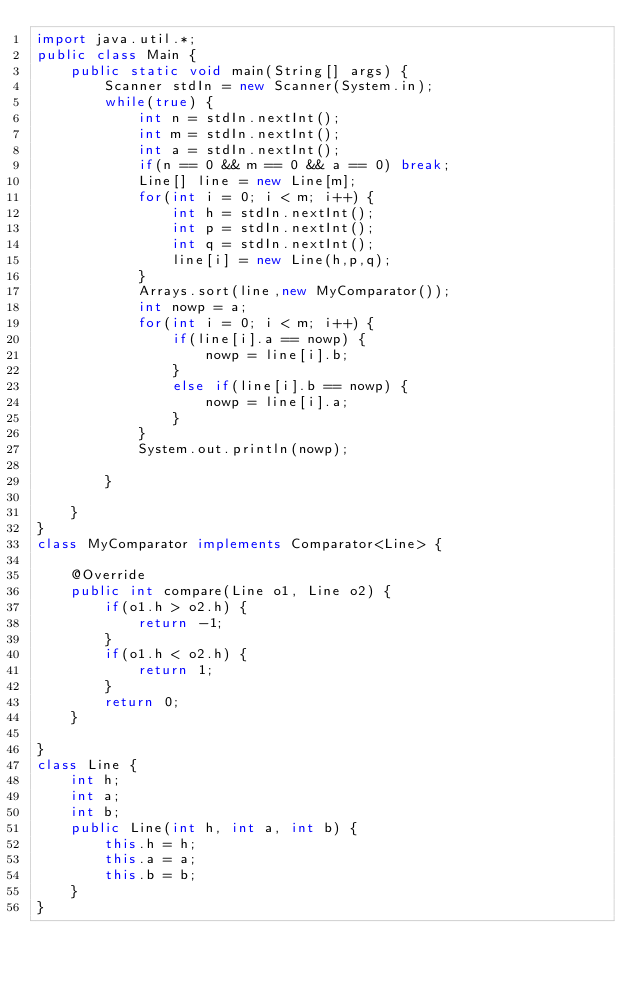<code> <loc_0><loc_0><loc_500><loc_500><_Java_>import java.util.*;
public class Main {
	public static void main(String[] args) {
		Scanner stdIn = new Scanner(System.in);
		while(true) {
			int n = stdIn.nextInt();
			int m = stdIn.nextInt();
			int a = stdIn.nextInt();
			if(n == 0 && m == 0 && a == 0) break;
			Line[] line = new Line[m];
			for(int i = 0; i < m; i++) {
				int h = stdIn.nextInt();
				int p = stdIn.nextInt();
				int q = stdIn.nextInt();
				line[i] = new Line(h,p,q);
			}
			Arrays.sort(line,new MyComparator());
			int nowp = a;
			for(int i = 0; i < m; i++) {
				if(line[i].a == nowp) {
					nowp = line[i].b;
				}
				else if(line[i].b == nowp) {
					nowp = line[i].a;
				}
			}
			System.out.println(nowp);
			
		}
		
	}
}
class MyComparator implements Comparator<Line> {

	@Override
	public int compare(Line o1, Line o2) {
		if(o1.h > o2.h) {
			return -1;
		}
		if(o1.h < o2.h) {
			return 1;
		}
		return 0;
	}
	
}
class Line {
	int h;
	int a;
	int b;
	public Line(int h, int a, int b) {
		this.h = h;
		this.a = a;
		this.b = b;
	}
}</code> 